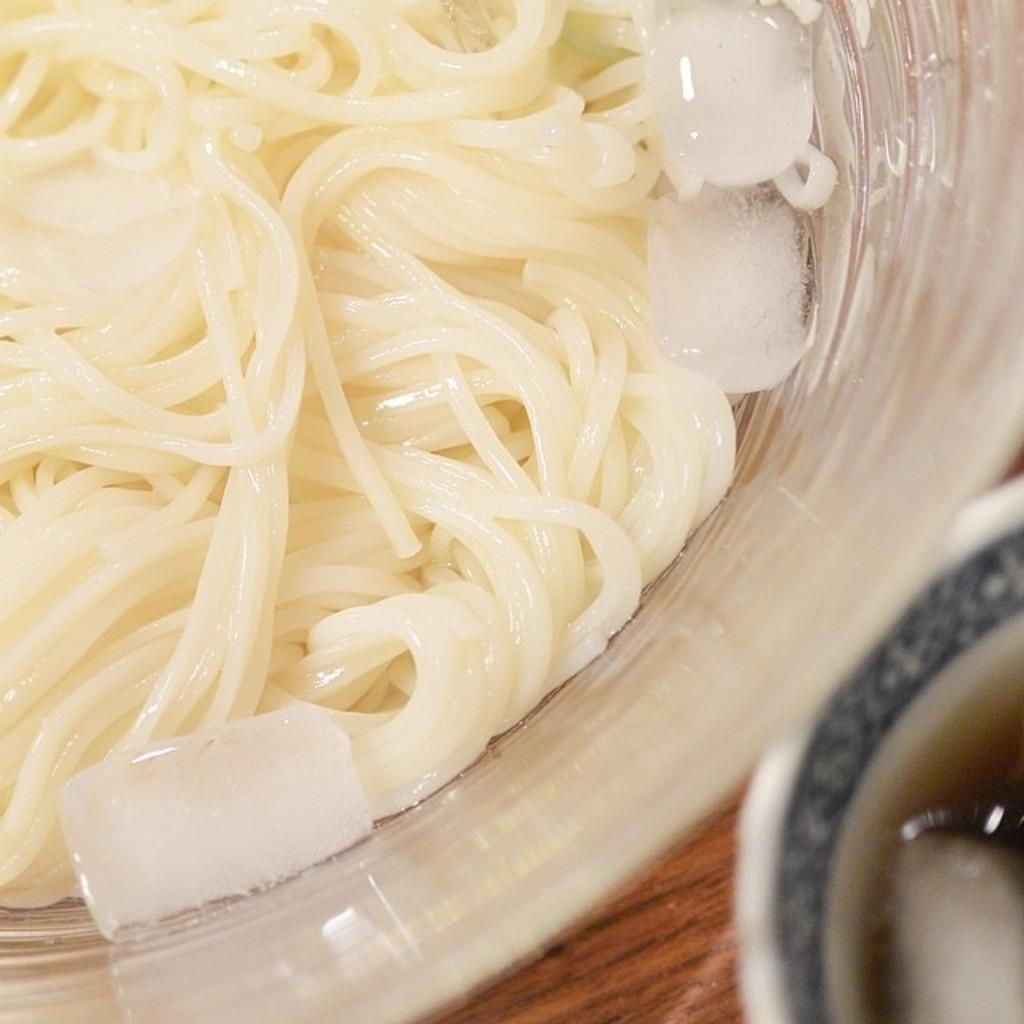What is in the bowl that is visible in the image? There are food items in a bowl in the image. What else can be seen in the image besides the bowl of food? There is a cup with liquid in it in the image. What type of surface is visible in the image? There is a wooden surface visible in the image. How many coils can be seen in the image? There are no coils present in the image. Are there any bears visible in the image? There are no bears present in the image. 